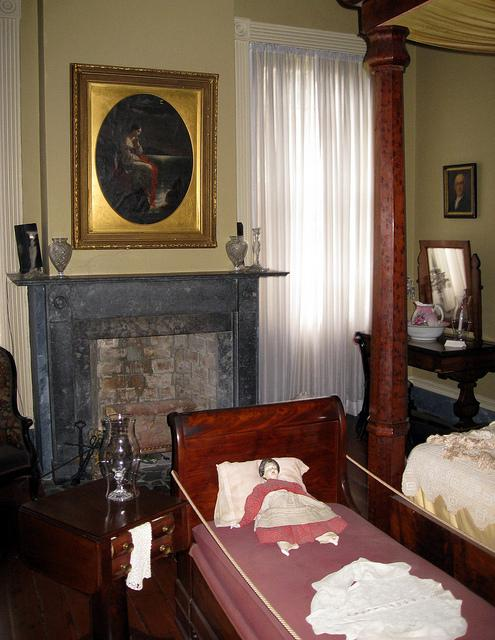What is the black structure against the wall used to contain? Please explain your reasoning. fire. The black structure against the wall is a fireplace used for making fires. 